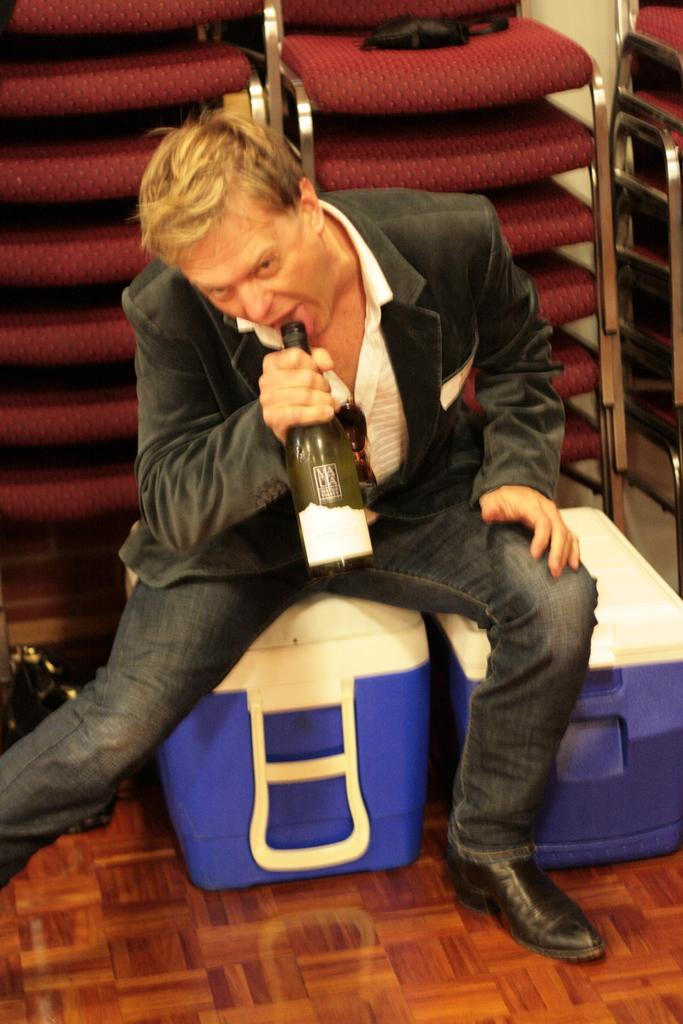Who is present in the image? There is a man in the image. What is the man wearing? The man is wearing a suit. What is the man doing in the image? The man is sitting. What is the man holding in his hand? The man is holding a bottle in his hand. What can be seen in the background of the image? There are chairs in the background of the image. What is located on the left side of the image? There is a black color bag on the left side of the image. Can you see any fog in the image? No, there is no fog visible in the image. What is the man's mode of transport in the image? The image does not show the man's mode of transport; it only shows him sitting and holding a bottle. 